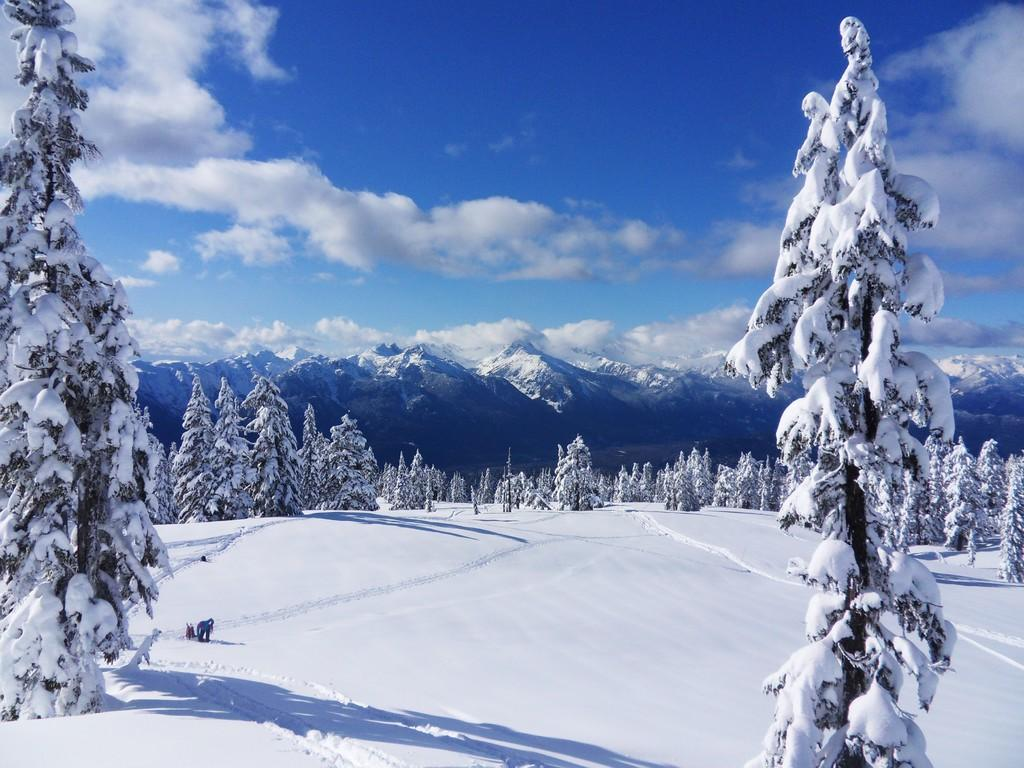What is the condition of the land in the image? The land in the image is covered with snow. What else is covered with snow in the image? The trees in the image are also covered with snow. What can be seen in the background of the image? There are mountains and the sky visible in the background of the image. What is the value of the suggestion made by the trees in the image? There is no suggestion made by the trees in the image, as trees do not make suggestions. 